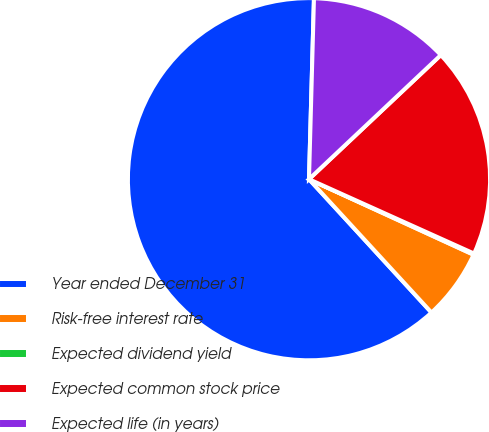<chart> <loc_0><loc_0><loc_500><loc_500><pie_chart><fcel>Year ended December 31<fcel>Risk-free interest rate<fcel>Expected dividend yield<fcel>Expected common stock price<fcel>Expected life (in years)<nl><fcel>62.27%<fcel>6.33%<fcel>0.11%<fcel>18.76%<fcel>12.54%<nl></chart> 